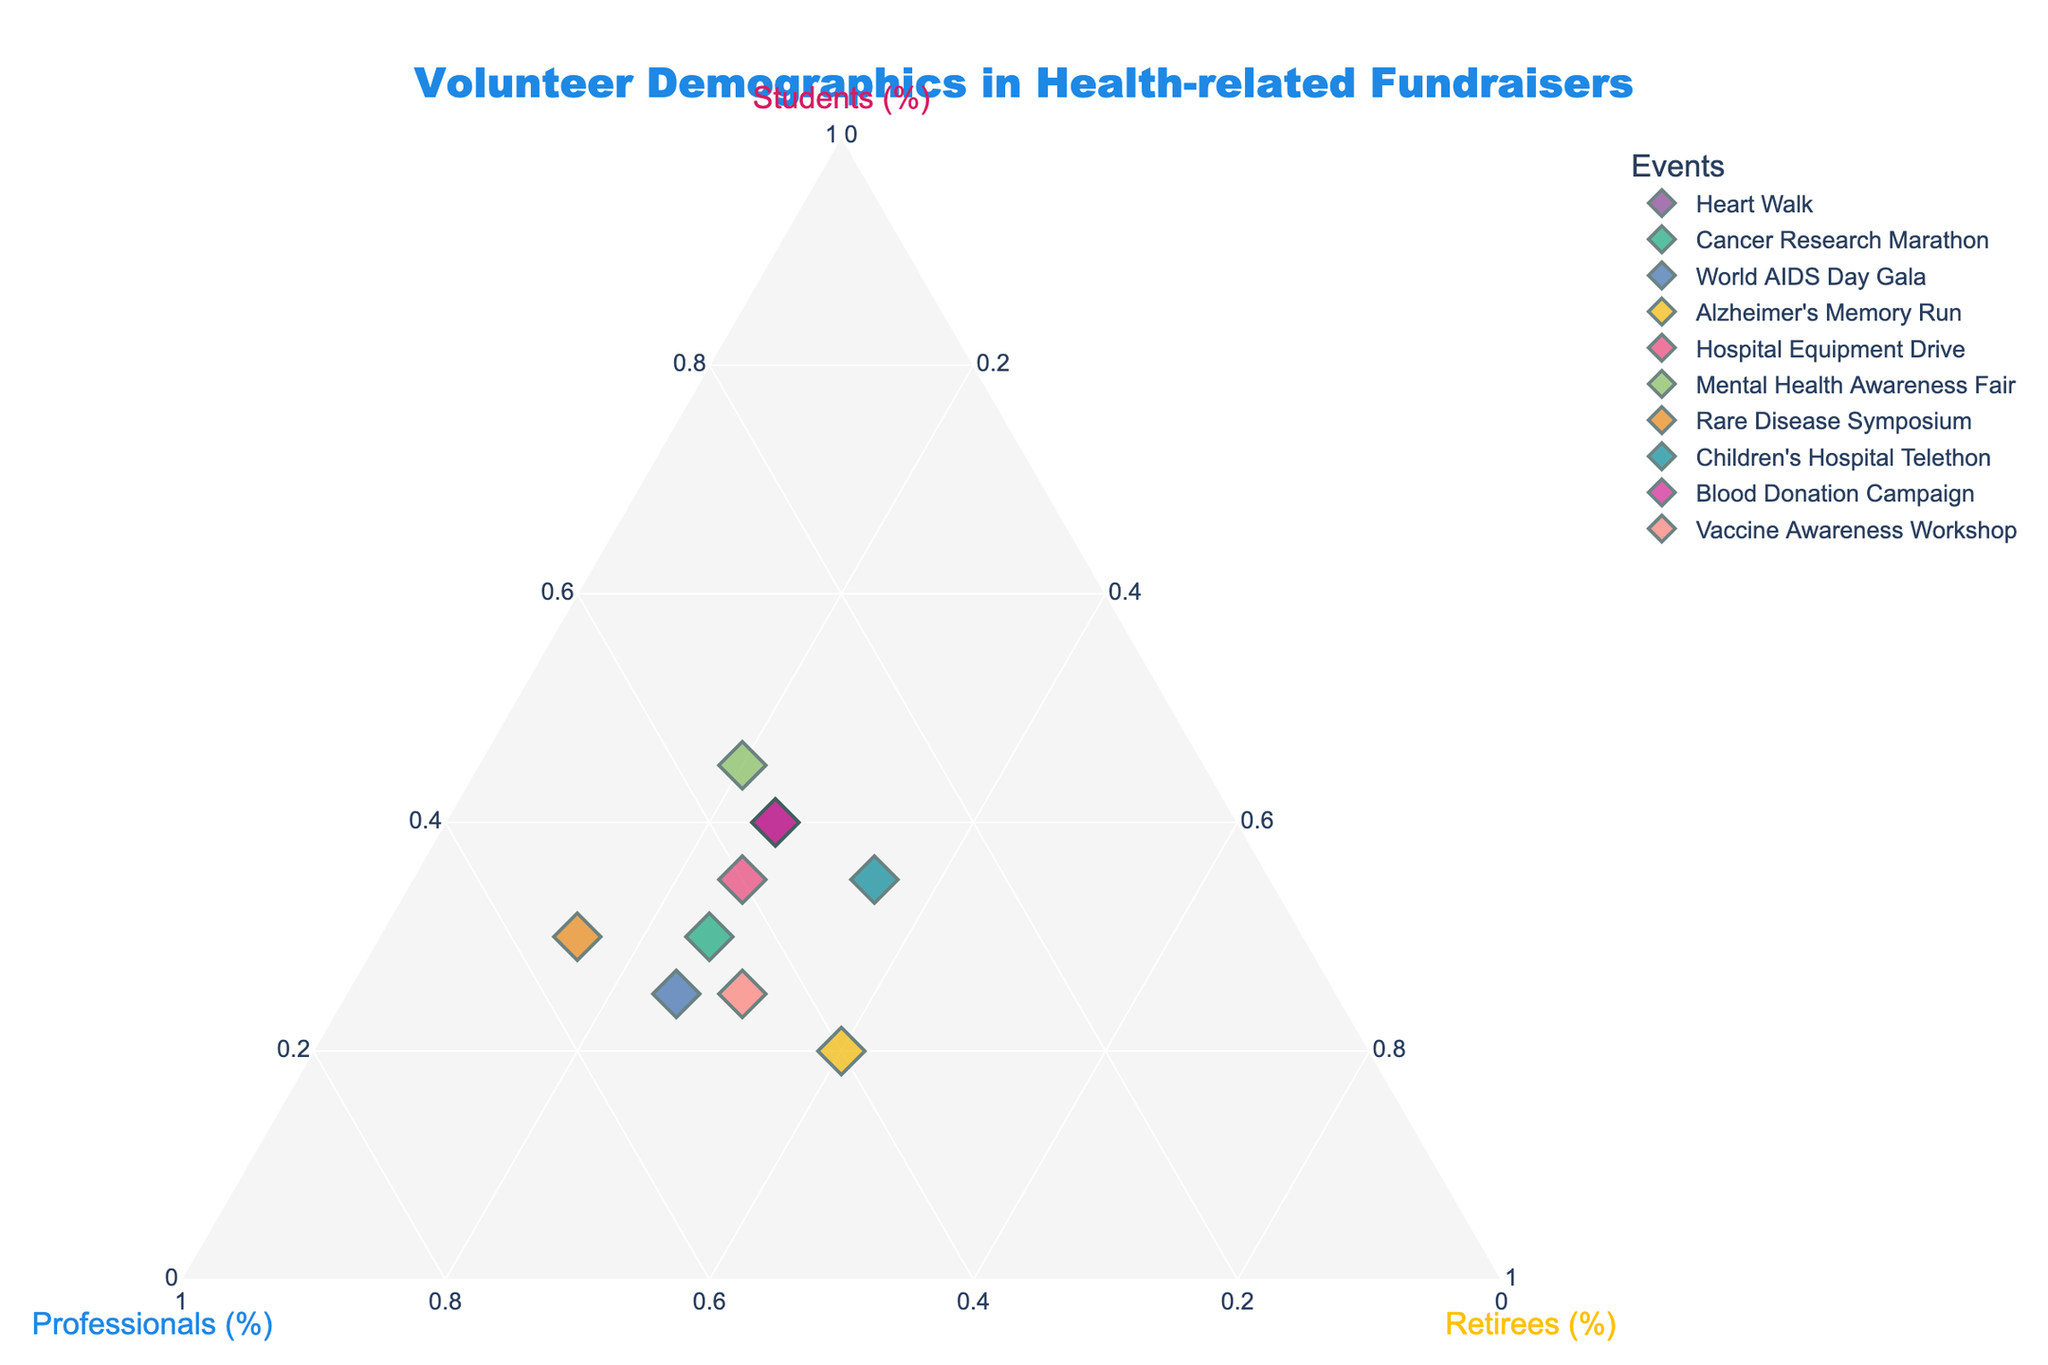what is the title of the ternary plot? The title is typically displayed at the top of the plot, providing a summary of what the plot represents. Look near the top center of the figure.
Answer: Volunteer Demographics in Health-related Fundraisers how many different events are represented in the plot? Each point on the plot corresponds to one of the events. By counting the distinct points, you can determine the number of different events.
Answer: 10 what is the range of values for the 'Students' axis? The 'Students' axis is one of the three axes on the ternary plot, usually marked with tick marks or labels. You can see the range by looking at the axis ticks and labels.
Answer: 0% to 50% which event has the highest percentage of professionals? Identify the point closest to the ‘Professionals’ vertex of the ternary plot, which indicates a higher proportion of professionals.
Answer: Rare Disease Symposium which event has an equal distribution of volunteers among all three categories? Look for the point close to the centroid of the ternary plot, indicating that the percentages for students, professionals, and retirees are similar.
Answer: Alzheimer's Memory Run how many events have more than 40% students participating? Locate the points closer to the 'Students' vertex and count how many fall within the range of over 40% on the students’ axis.
Answer: 2 For the Vaccine Awareness Workshop, what is the combined percentage of professionals and retirees? On the ternary plot, find the point for Vaccine Awareness Workshop and add the percentages of professionals and retirees by visual inspection of the plot.
Answer: 75% compare the percentage of retirees between the Heart Walk and the Children's Hospital Telethon. which event has a higher percentage? Identify the points for both events on the ternary plot and compare their proximities to the 'Retirees' axis.
Answer: Children's Hospital Telethon which event has the smallest percentage of retirees? Find the point closest to the opposite side of the 'Retirees' axis on the ternary plot to determine the event with the smallest percentage of retirees.
Answer: Rare Disease Symposium order the events by the percentage of students from highest to lowest. Locate each point representing an event on the ternary plot and order them based on their distance to the 'Students' vertex from closest to farthest.
Answer: Mental Health Awareness Fair, Heart Walk, Blood Donation Campaign, Hospital Equipment Drive, Children’s Hospital Telethon, Cancer Research Marathon, Rare Disease Symposium, Vaccine Awareness Workshop, World AIDS Day Gala, Alzheimer's Memory Run 